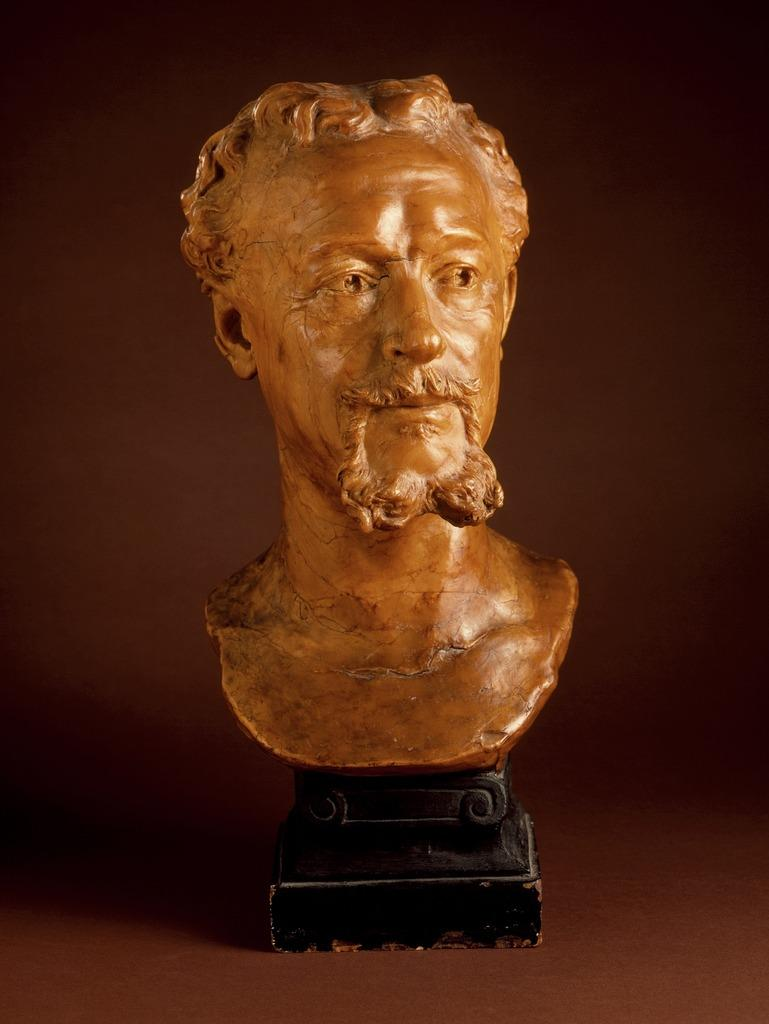What is the main subject of the image? There is a sculpture in the image. What can you tell me about the appearance of the sculpture? The sculpture is brown in color. What is the sculpture depicting? The sculpture is of a man. What type of advice is the man in the sculpture giving to the boats in the image? There are no boats present in the image, and the man in the sculpture is not giving any advice. 